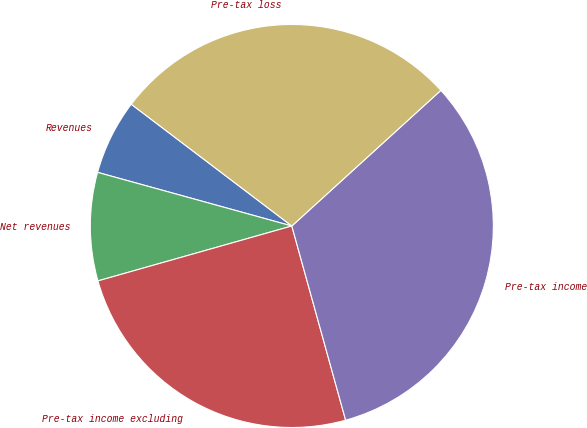Convert chart to OTSL. <chart><loc_0><loc_0><loc_500><loc_500><pie_chart><fcel>Revenues<fcel>Net revenues<fcel>Pre-tax income excluding<fcel>Pre-tax income<fcel>Pre-tax loss<nl><fcel>6.04%<fcel>8.68%<fcel>24.91%<fcel>32.45%<fcel>27.92%<nl></chart> 